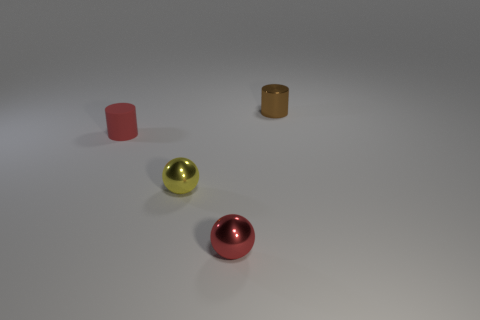Is the number of tiny yellow metal objects behind the red cylinder less than the number of red cylinders behind the tiny red shiny sphere? Yes, indeed, the number of tiny yellow metal objects, which we can observe to be one, is fewer than the number of red cylinders behind the tiny red shiny sphere, as there are no red cylinders behind the sphere. 